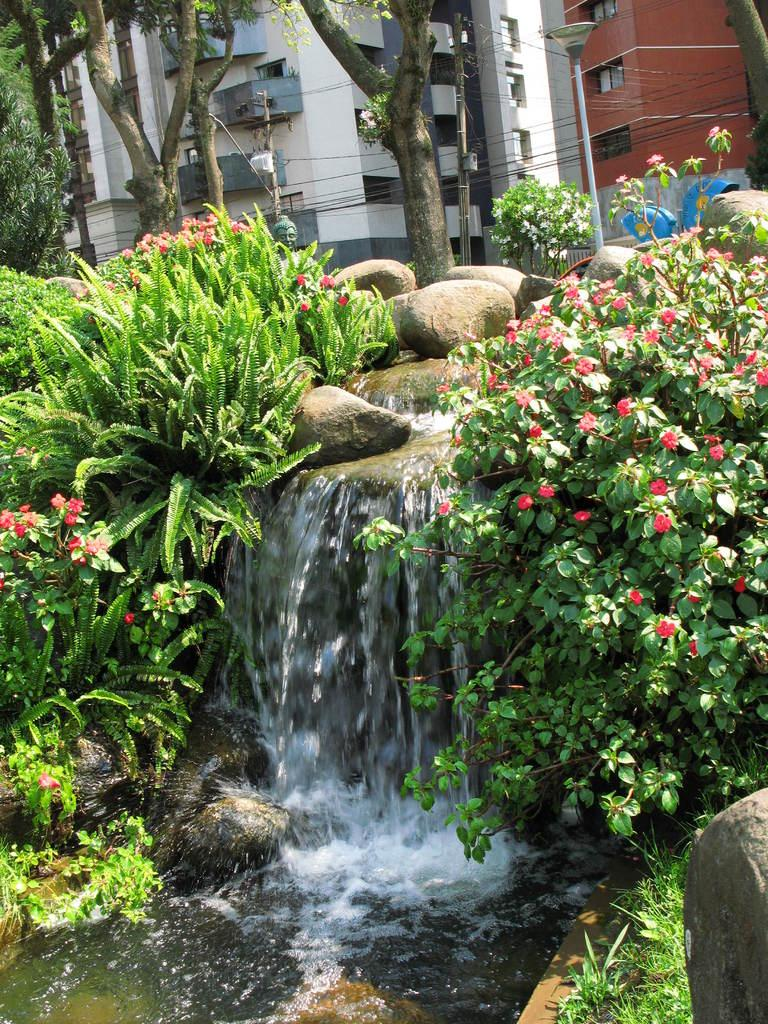What natural feature is the main subject of the image? There is a waterfall in the image. What type of geological formation can be seen in the image? Rocks are present in the image. What type of vegetation is visible in the image? Flowers are associated with plants in the image, and there are also trees present. Are there any man-made structures visible in the image? Yes, there are buildings in the image. What type of acoustics can be heard in the image? The image is a still picture and does not have any sound or acoustics associated with it. What type of thing is present in the image? This question is too vague, as the image contains multiple elements such as a waterfall, rocks, plants, trees, and buildings. Please specify which element you are referring to. 